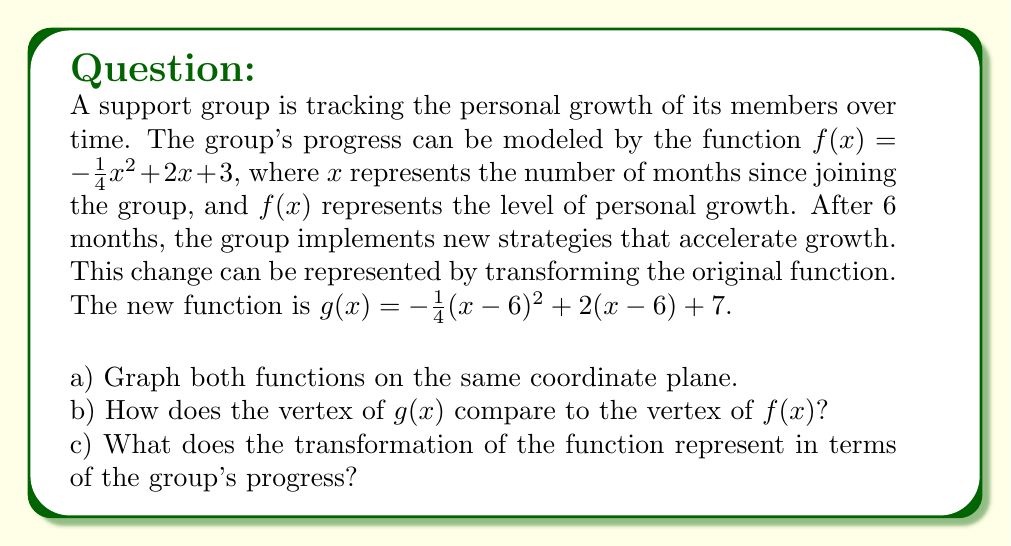Can you answer this question? Let's approach this step-by-step:

a) To graph both functions, we need to identify the transformations applied to $f(x)$ to get $g(x)$.

$f(x) = -\frac{1}{4}x^2 + 2x + 3$
$g(x) = -\frac{1}{4}(x-6)^2 + 2(x-6) + 7$

We can see that $g(x)$ is a horizontal shift of $f(x)$ by 6 units to the right, and a vertical shift of 4 units up.

[asy]
import graph;
size(200);
real f(real x) {return -1/4*x^2 + 2*x + 3;}
real g(real x) {return -1/4*(x-6)^2 + 2*(x-6) + 7;}
draw(graph(f,-2,10),blue);
draw(graph(g,-2,14),red);
xaxis("x",arrow=Arrow);
yaxis("y",arrow=Arrow);
label("f(x)",(-1,f(-1)),NW,blue);
label("g(x)",(7,g(7)),NE,red);
[/asy]

b) To compare the vertices, let's find them for both functions:

For $f(x) = -\frac{1}{4}x^2 + 2x + 3$:
The vertex form of a parabola is $a(x-h)^2 + k$, where $(h,k)$ is the vertex.
Completing the square:
$f(x) = -\frac{1}{4}(x^2 - 8x) + 3$
$= -\frac{1}{4}(x^2 - 8x + 16 - 16) + 3$
$= -\frac{1}{4}((x-4)^2 - 16) + 3$
$= -\frac{1}{4}(x-4)^2 + 4 + 3$
$= -\frac{1}{4}(x-4)^2 + 7$

So the vertex of $f(x)$ is $(4,7)$.

For $g(x) = -\frac{1}{4}(x-6)^2 + 2(x-6) + 7$:
This is already in the form $a(x-h)^2 + b(x-h) + c$.
Completing the square:
$g(x) = -\frac{1}{4}(x-6)^2 + 2(x-6) + 7$
$= -\frac{1}{4}(x-6)^2 + 2(x-6) + 7 + 4 - 4$
$= -\frac{1}{4}(x-6)^2 + 2(x-6) + 4 + 3$
$= -\frac{1}{4}((x-6)^2 - 8(x-6)) + 7$
$= -\frac{1}{4}((x-6)^2 - 8(x-6) + 16 - 16) + 7$
$= -\frac{1}{4}((x-6-4)^2 - 16) + 7$
$= -\frac{1}{4}(x-10)^2 + 4 + 7$
$= -\frac{1}{4}(x-10)^2 + 11$

So the vertex of $g(x)$ is $(10,11)$.

The vertex of $g(x)$ is 6 units to the right and 4 units up compared to the vertex of $f(x)$.

c) The transformation represents:
1. A horizontal shift of 6 units right, meaning the peak growth occurs 6 months later than in the original model.
2. A vertical shift of 4 units up, indicating that the overall level of personal growth has increased by 4 units at every point in time.

This suggests that the new strategies implemented after 6 months have both delayed the peak growth period and increased the overall level of growth for all members of the group.
Answer: a) See the graph in the explanation.
b) The vertex of $g(x)$ is $(10,11)$, which is 6 units to the right and 4 units up compared to the vertex of $f(x)$ at $(4,7)$.
c) The transformation represents a delay in peak growth by 6 months and an overall increase in personal growth by 4 units for all group members. 